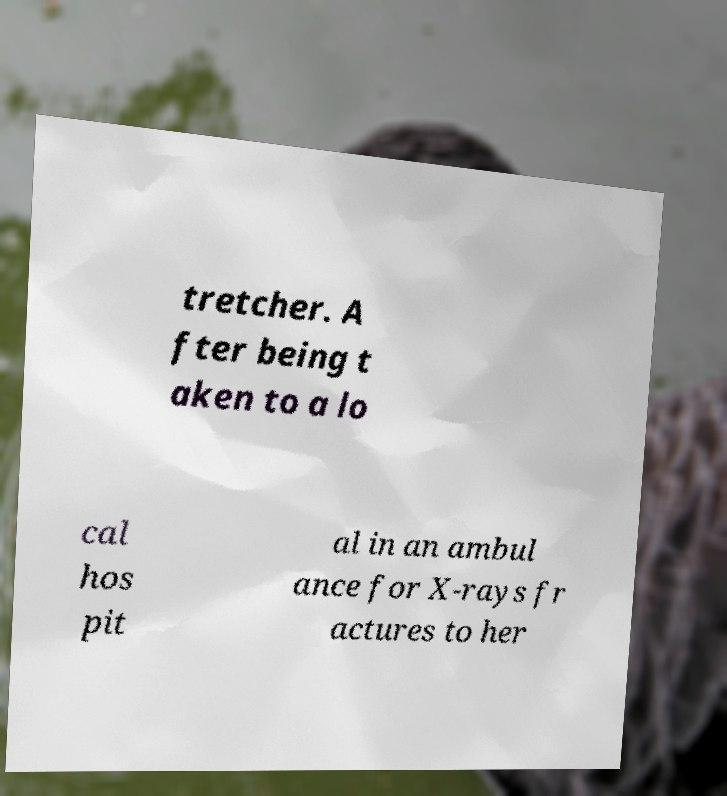Please identify and transcribe the text found in this image. tretcher. A fter being t aken to a lo cal hos pit al in an ambul ance for X-rays fr actures to her 